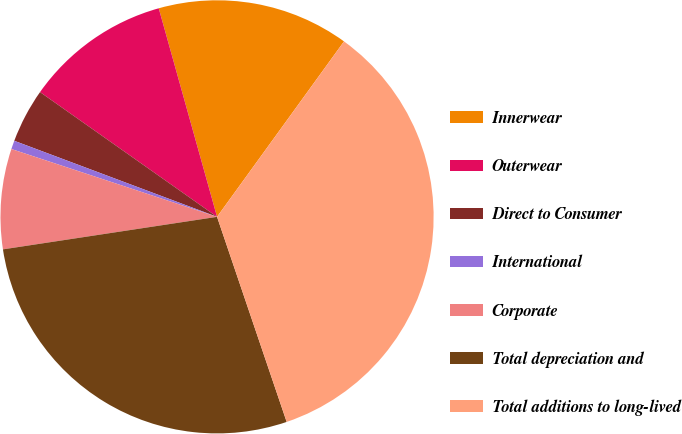Convert chart to OTSL. <chart><loc_0><loc_0><loc_500><loc_500><pie_chart><fcel>Innerwear<fcel>Outerwear<fcel>Direct to Consumer<fcel>International<fcel>Corporate<fcel>Total depreciation and<fcel>Total additions to long-lived<nl><fcel>14.31%<fcel>10.89%<fcel>4.06%<fcel>0.64%<fcel>7.47%<fcel>27.81%<fcel>34.82%<nl></chart> 